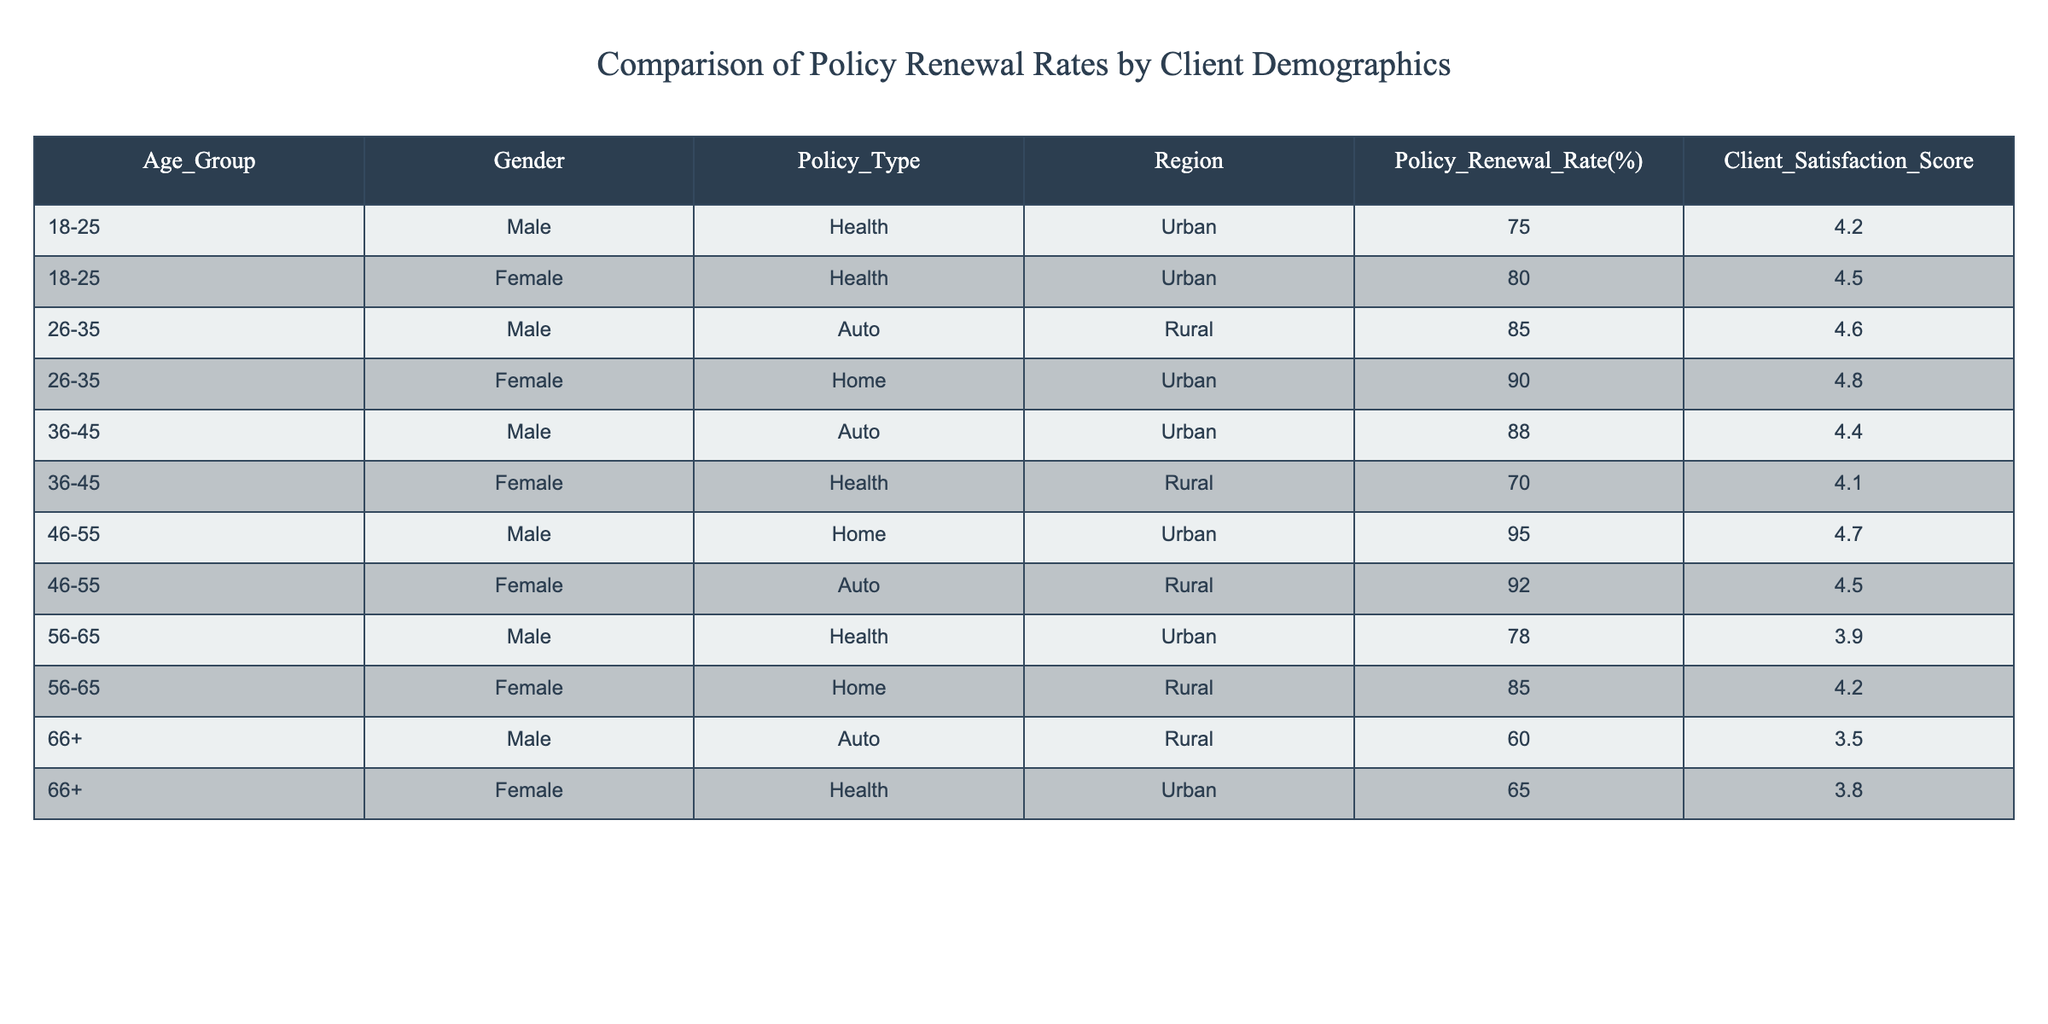What is the policy renewal rate for the 36-45 age group? The renewal rate for the 36-45 age group can be found by looking at the entries for that age group in the table. For males, the rate is 88%, and for females, it is 70%.
Answer: 88% (Male), 70% (Female) Which gender has a higher average policy renewal rate? To find the average renewal rate for each gender, we first sum up the renewal rates and then divide by the number of entries for each gender. Males: (75 + 85 + 88 + 95 + 78 + 60) / 6 = 77.5%. Females: (80 + 90 + 70 + 92 + 85 + 65) / 6 = 80.5%. Thus, females have a higher average.
Answer: Female Is the policy renewal rate for the 18-25 age group higher for males or females? In the table, the renewal rate for males in the 18-25 age group is 75%, while for females it is 80%. Therefore, females have a higher rate in this age group.
Answer: Female What is the overall policy renewal rate across all age groups for the Health policy type? To find the overall renewal rate for the Health policy type, sum the renewal rates of the relevant entries. There are two entries: males at 75% and females at 80% in the 18-25 age group, and females at 70% in the 36-45 age group and males at 78% in the 56-65 age group. The total is (75 + 80 + 70 + 78)/4 = 75.75%.
Answer: 75.75% Is the Client Satisfaction Score for females in the 26-35 age group higher than for males in the same age group? Looking at the table, the Client Satisfaction Score for females in the 26-35 age group is 4.8, while for males in the same age group, it is 4.6. Therefore, yes, females have a higher score.
Answer: Yes What is the difference in policy renewal rates between the 46-55 and 56-65 age groups for males? The renewal rate for males in the 46-55 age group is 95%, while in the 56-65 age group, it is 78%. The difference is 95 - 78 = 17%.
Answer: 17% Which region has the highest overall policy renewal rate? By comparing the renewal rates for each region summing the relevant entries, we find: Urban = (75 + 80 + 88 + 95 + 78) / 5 = 83.2%, Rural = (85 + 90 + 70 + 92 + 60 + 65) / 6 = 75.5%. Urban has the highest overall rate.
Answer: Urban In which age group is the Client Satisfaction Score the lowest for males? The lowest Client Satisfaction Score for males can be found by comparing the scores across age groups. The scores are 4.2 (18-25), 4.6 (26-35), 4.4 (36-45), 4.7 (46-55), 3.9 (56-65), and 3.5 (66+). The lowest score is 3.5 in the 66+ age group.
Answer: 66+ What is the average Client Satisfaction Score for all policy types combined? To calculate the average Client Satisfaction Score, we add all the scores and divide by the total number of entries. The scores are 4.2, 4.5, 4.6, 4.8, 4.4, 4.1, 4.7, 4.5, 3.9, 4.2, 3.5, and 3.8. The total is 52.8, and there are 12 entries, giving an average of 52.8 / 12 = 4.4.
Answer: 4.4 